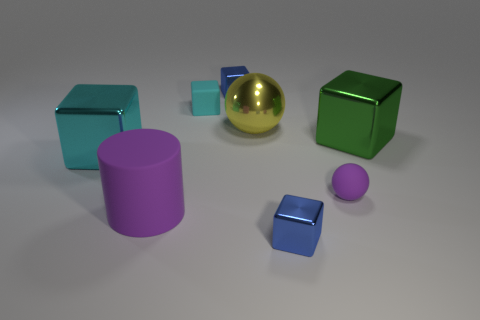Subtract all small cyan blocks. How many blocks are left? 4 Subtract all green blocks. How many blocks are left? 4 Subtract all yellow cubes. Subtract all yellow cylinders. How many cubes are left? 5 Add 1 large yellow spheres. How many objects exist? 9 Subtract all blocks. How many objects are left? 3 Add 8 small cyan objects. How many small cyan objects exist? 9 Subtract 1 blue cubes. How many objects are left? 7 Subtract all large yellow things. Subtract all big metallic spheres. How many objects are left? 6 Add 5 green metal objects. How many green metal objects are left? 6 